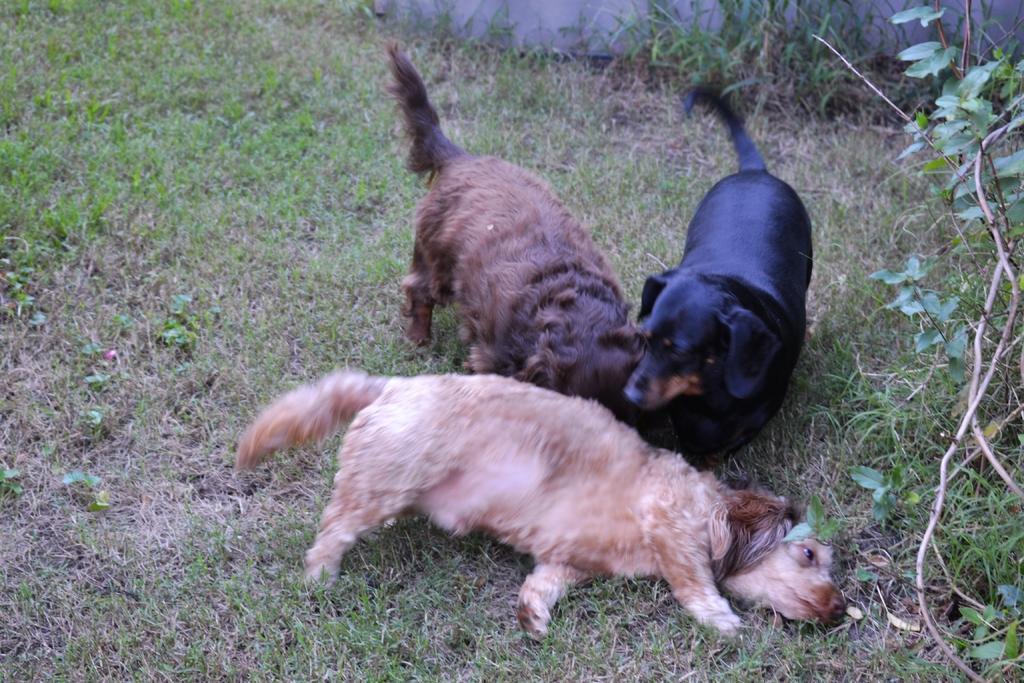Describe this image in one or two sentences. There are three small puppies laying on the grass,around the puppies there are small plants. They are of brown,black and cream color. 